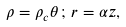<formula> <loc_0><loc_0><loc_500><loc_500>\rho = \rho _ { c } \theta \, ; \, r = \alpha z ,</formula> 